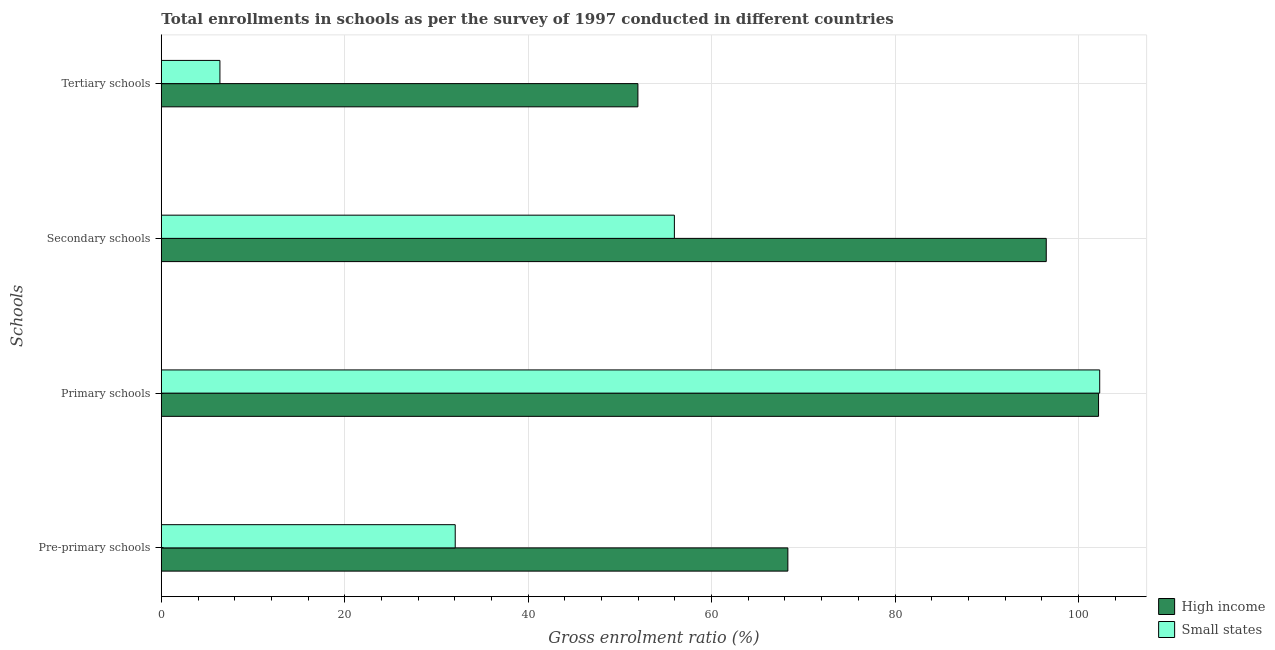Are the number of bars per tick equal to the number of legend labels?
Ensure brevity in your answer.  Yes. How many bars are there on the 1st tick from the top?
Your response must be concise. 2. What is the label of the 3rd group of bars from the top?
Give a very brief answer. Primary schools. What is the gross enrolment ratio in primary schools in High income?
Offer a very short reply. 102.19. Across all countries, what is the maximum gross enrolment ratio in secondary schools?
Your response must be concise. 96.49. Across all countries, what is the minimum gross enrolment ratio in tertiary schools?
Offer a very short reply. 6.39. In which country was the gross enrolment ratio in tertiary schools minimum?
Your answer should be compact. Small states. What is the total gross enrolment ratio in tertiary schools in the graph?
Your answer should be very brief. 58.35. What is the difference between the gross enrolment ratio in secondary schools in High income and that in Small states?
Your answer should be compact. 40.55. What is the difference between the gross enrolment ratio in primary schools in Small states and the gross enrolment ratio in secondary schools in High income?
Provide a short and direct response. 5.83. What is the average gross enrolment ratio in secondary schools per country?
Your answer should be very brief. 76.21. What is the difference between the gross enrolment ratio in pre-primary schools and gross enrolment ratio in primary schools in High income?
Offer a terse response. -33.87. What is the ratio of the gross enrolment ratio in pre-primary schools in High income to that in Small states?
Offer a terse response. 2.13. Is the difference between the gross enrolment ratio in primary schools in Small states and High income greater than the difference between the gross enrolment ratio in tertiary schools in Small states and High income?
Ensure brevity in your answer.  Yes. What is the difference between the highest and the second highest gross enrolment ratio in secondary schools?
Give a very brief answer. 40.55. What is the difference between the highest and the lowest gross enrolment ratio in secondary schools?
Make the answer very short. 40.55. Is it the case that in every country, the sum of the gross enrolment ratio in tertiary schools and gross enrolment ratio in secondary schools is greater than the sum of gross enrolment ratio in primary schools and gross enrolment ratio in pre-primary schools?
Make the answer very short. Yes. What does the 2nd bar from the top in Tertiary schools represents?
Provide a succinct answer. High income. What does the 2nd bar from the bottom in Secondary schools represents?
Provide a short and direct response. Small states. Is it the case that in every country, the sum of the gross enrolment ratio in pre-primary schools and gross enrolment ratio in primary schools is greater than the gross enrolment ratio in secondary schools?
Make the answer very short. Yes. Are all the bars in the graph horizontal?
Offer a terse response. Yes. What is the difference between two consecutive major ticks on the X-axis?
Your response must be concise. 20. Does the graph contain any zero values?
Ensure brevity in your answer.  No. Where does the legend appear in the graph?
Your answer should be compact. Bottom right. How are the legend labels stacked?
Provide a short and direct response. Vertical. What is the title of the graph?
Your answer should be compact. Total enrollments in schools as per the survey of 1997 conducted in different countries. Does "Arab World" appear as one of the legend labels in the graph?
Your response must be concise. No. What is the label or title of the Y-axis?
Offer a very short reply. Schools. What is the Gross enrolment ratio (%) in High income in Pre-primary schools?
Your answer should be compact. 68.32. What is the Gross enrolment ratio (%) of Small states in Pre-primary schools?
Ensure brevity in your answer.  32.05. What is the Gross enrolment ratio (%) in High income in Primary schools?
Provide a succinct answer. 102.19. What is the Gross enrolment ratio (%) of Small states in Primary schools?
Offer a very short reply. 102.32. What is the Gross enrolment ratio (%) of High income in Secondary schools?
Keep it short and to the point. 96.49. What is the Gross enrolment ratio (%) of Small states in Secondary schools?
Offer a terse response. 55.94. What is the Gross enrolment ratio (%) of High income in Tertiary schools?
Your response must be concise. 51.96. What is the Gross enrolment ratio (%) of Small states in Tertiary schools?
Offer a very short reply. 6.39. Across all Schools, what is the maximum Gross enrolment ratio (%) of High income?
Provide a succinct answer. 102.19. Across all Schools, what is the maximum Gross enrolment ratio (%) in Small states?
Offer a terse response. 102.32. Across all Schools, what is the minimum Gross enrolment ratio (%) in High income?
Provide a succinct answer. 51.96. Across all Schools, what is the minimum Gross enrolment ratio (%) in Small states?
Your answer should be compact. 6.39. What is the total Gross enrolment ratio (%) in High income in the graph?
Provide a succinct answer. 318.96. What is the total Gross enrolment ratio (%) in Small states in the graph?
Your response must be concise. 196.69. What is the difference between the Gross enrolment ratio (%) of High income in Pre-primary schools and that in Primary schools?
Your answer should be very brief. -33.87. What is the difference between the Gross enrolment ratio (%) of Small states in Pre-primary schools and that in Primary schools?
Provide a succinct answer. -70.27. What is the difference between the Gross enrolment ratio (%) of High income in Pre-primary schools and that in Secondary schools?
Your answer should be very brief. -28.17. What is the difference between the Gross enrolment ratio (%) of Small states in Pre-primary schools and that in Secondary schools?
Your answer should be compact. -23.9. What is the difference between the Gross enrolment ratio (%) of High income in Pre-primary schools and that in Tertiary schools?
Ensure brevity in your answer.  16.35. What is the difference between the Gross enrolment ratio (%) of Small states in Pre-primary schools and that in Tertiary schools?
Your answer should be very brief. 25.66. What is the difference between the Gross enrolment ratio (%) of High income in Primary schools and that in Secondary schools?
Offer a very short reply. 5.7. What is the difference between the Gross enrolment ratio (%) in Small states in Primary schools and that in Secondary schools?
Your response must be concise. 46.37. What is the difference between the Gross enrolment ratio (%) in High income in Primary schools and that in Tertiary schools?
Your answer should be very brief. 50.23. What is the difference between the Gross enrolment ratio (%) of Small states in Primary schools and that in Tertiary schools?
Your answer should be compact. 95.93. What is the difference between the Gross enrolment ratio (%) of High income in Secondary schools and that in Tertiary schools?
Provide a succinct answer. 44.52. What is the difference between the Gross enrolment ratio (%) of Small states in Secondary schools and that in Tertiary schools?
Give a very brief answer. 49.55. What is the difference between the Gross enrolment ratio (%) of High income in Pre-primary schools and the Gross enrolment ratio (%) of Small states in Primary schools?
Your answer should be compact. -34. What is the difference between the Gross enrolment ratio (%) in High income in Pre-primary schools and the Gross enrolment ratio (%) in Small states in Secondary schools?
Provide a short and direct response. 12.37. What is the difference between the Gross enrolment ratio (%) in High income in Pre-primary schools and the Gross enrolment ratio (%) in Small states in Tertiary schools?
Ensure brevity in your answer.  61.93. What is the difference between the Gross enrolment ratio (%) of High income in Primary schools and the Gross enrolment ratio (%) of Small states in Secondary schools?
Provide a succinct answer. 46.25. What is the difference between the Gross enrolment ratio (%) of High income in Primary schools and the Gross enrolment ratio (%) of Small states in Tertiary schools?
Provide a succinct answer. 95.8. What is the difference between the Gross enrolment ratio (%) in High income in Secondary schools and the Gross enrolment ratio (%) in Small states in Tertiary schools?
Offer a terse response. 90.1. What is the average Gross enrolment ratio (%) of High income per Schools?
Provide a short and direct response. 79.74. What is the average Gross enrolment ratio (%) of Small states per Schools?
Ensure brevity in your answer.  49.17. What is the difference between the Gross enrolment ratio (%) of High income and Gross enrolment ratio (%) of Small states in Pre-primary schools?
Make the answer very short. 36.27. What is the difference between the Gross enrolment ratio (%) of High income and Gross enrolment ratio (%) of Small states in Primary schools?
Offer a terse response. -0.13. What is the difference between the Gross enrolment ratio (%) in High income and Gross enrolment ratio (%) in Small states in Secondary schools?
Offer a very short reply. 40.55. What is the difference between the Gross enrolment ratio (%) of High income and Gross enrolment ratio (%) of Small states in Tertiary schools?
Offer a terse response. 45.58. What is the ratio of the Gross enrolment ratio (%) in High income in Pre-primary schools to that in Primary schools?
Offer a terse response. 0.67. What is the ratio of the Gross enrolment ratio (%) in Small states in Pre-primary schools to that in Primary schools?
Offer a terse response. 0.31. What is the ratio of the Gross enrolment ratio (%) of High income in Pre-primary schools to that in Secondary schools?
Give a very brief answer. 0.71. What is the ratio of the Gross enrolment ratio (%) of Small states in Pre-primary schools to that in Secondary schools?
Offer a terse response. 0.57. What is the ratio of the Gross enrolment ratio (%) in High income in Pre-primary schools to that in Tertiary schools?
Make the answer very short. 1.31. What is the ratio of the Gross enrolment ratio (%) of Small states in Pre-primary schools to that in Tertiary schools?
Ensure brevity in your answer.  5.02. What is the ratio of the Gross enrolment ratio (%) in High income in Primary schools to that in Secondary schools?
Give a very brief answer. 1.06. What is the ratio of the Gross enrolment ratio (%) of Small states in Primary schools to that in Secondary schools?
Your response must be concise. 1.83. What is the ratio of the Gross enrolment ratio (%) of High income in Primary schools to that in Tertiary schools?
Provide a succinct answer. 1.97. What is the ratio of the Gross enrolment ratio (%) in Small states in Primary schools to that in Tertiary schools?
Make the answer very short. 16.01. What is the ratio of the Gross enrolment ratio (%) in High income in Secondary schools to that in Tertiary schools?
Keep it short and to the point. 1.86. What is the ratio of the Gross enrolment ratio (%) of Small states in Secondary schools to that in Tertiary schools?
Offer a very short reply. 8.76. What is the difference between the highest and the second highest Gross enrolment ratio (%) of High income?
Keep it short and to the point. 5.7. What is the difference between the highest and the second highest Gross enrolment ratio (%) of Small states?
Offer a terse response. 46.37. What is the difference between the highest and the lowest Gross enrolment ratio (%) in High income?
Keep it short and to the point. 50.23. What is the difference between the highest and the lowest Gross enrolment ratio (%) in Small states?
Provide a short and direct response. 95.93. 